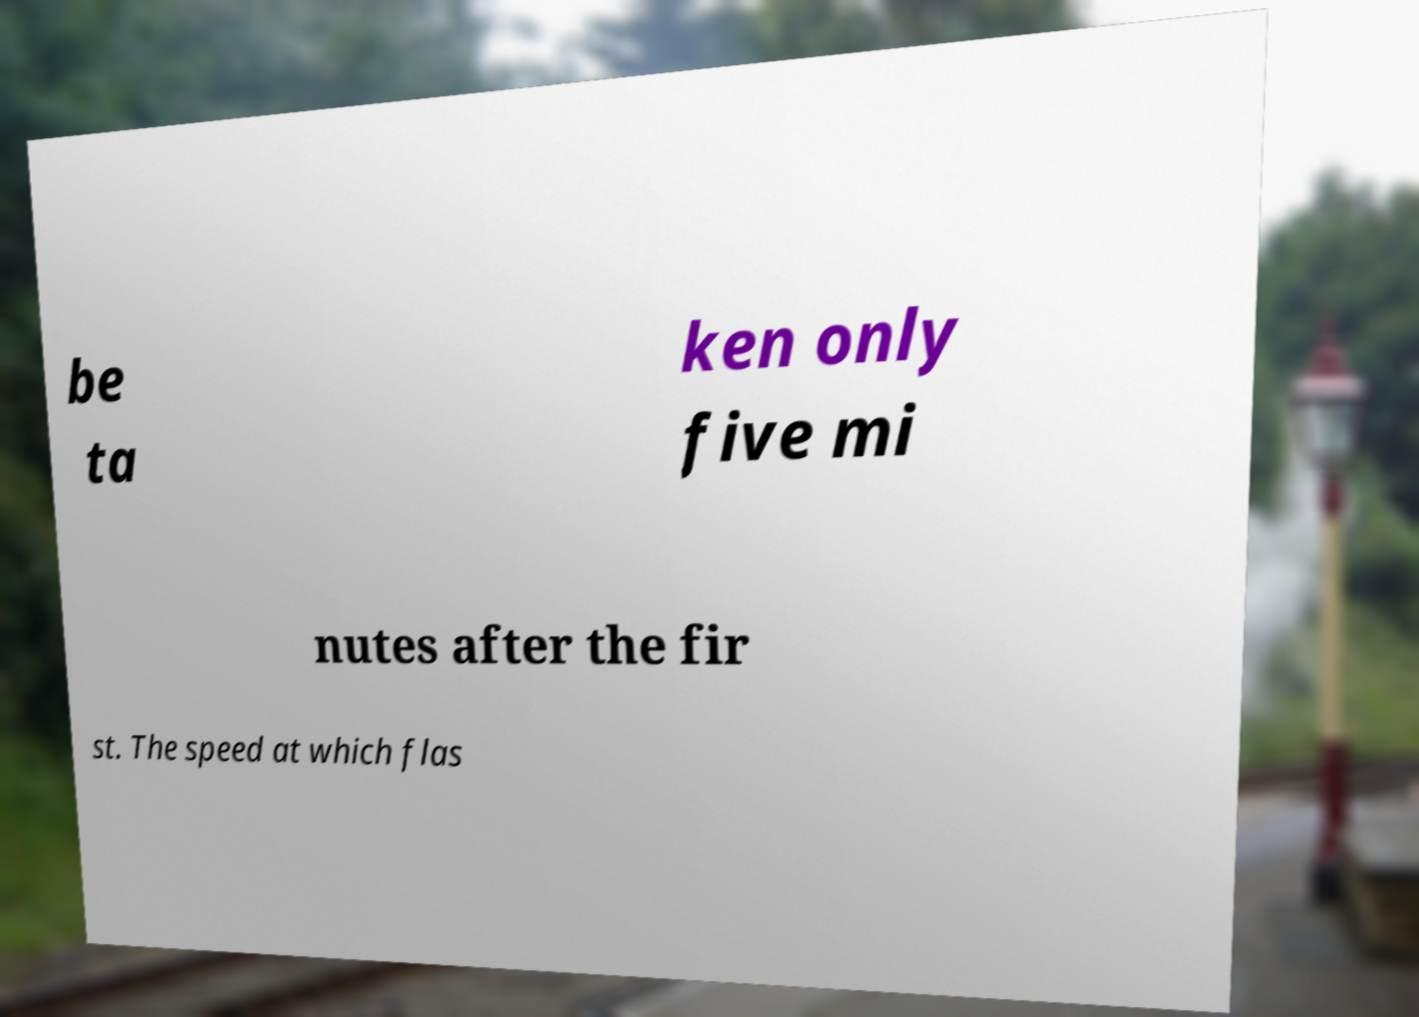Can you read and provide the text displayed in the image?This photo seems to have some interesting text. Can you extract and type it out for me? be ta ken only five mi nutes after the fir st. The speed at which flas 